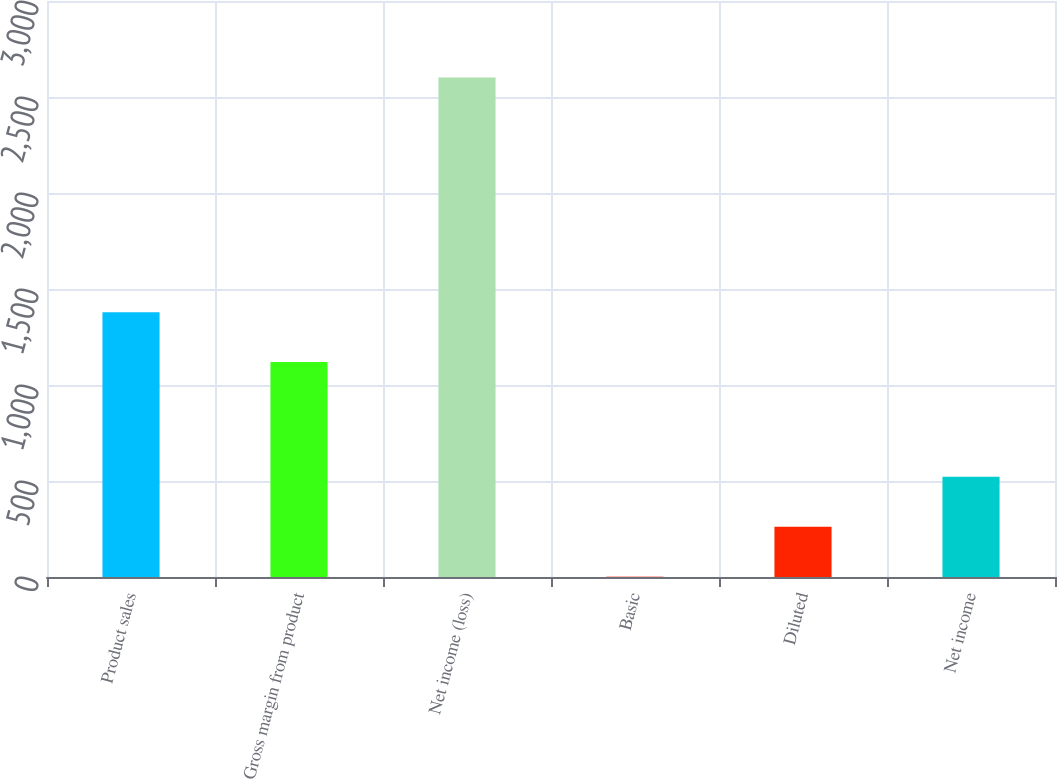Convert chart. <chart><loc_0><loc_0><loc_500><loc_500><bar_chart><fcel>Product sales<fcel>Gross margin from product<fcel>Net income (loss)<fcel>Basic<fcel>Diluted<fcel>Net income<nl><fcel>1379.35<fcel>1119.4<fcel>2601.6<fcel>2.1<fcel>262.05<fcel>522<nl></chart> 